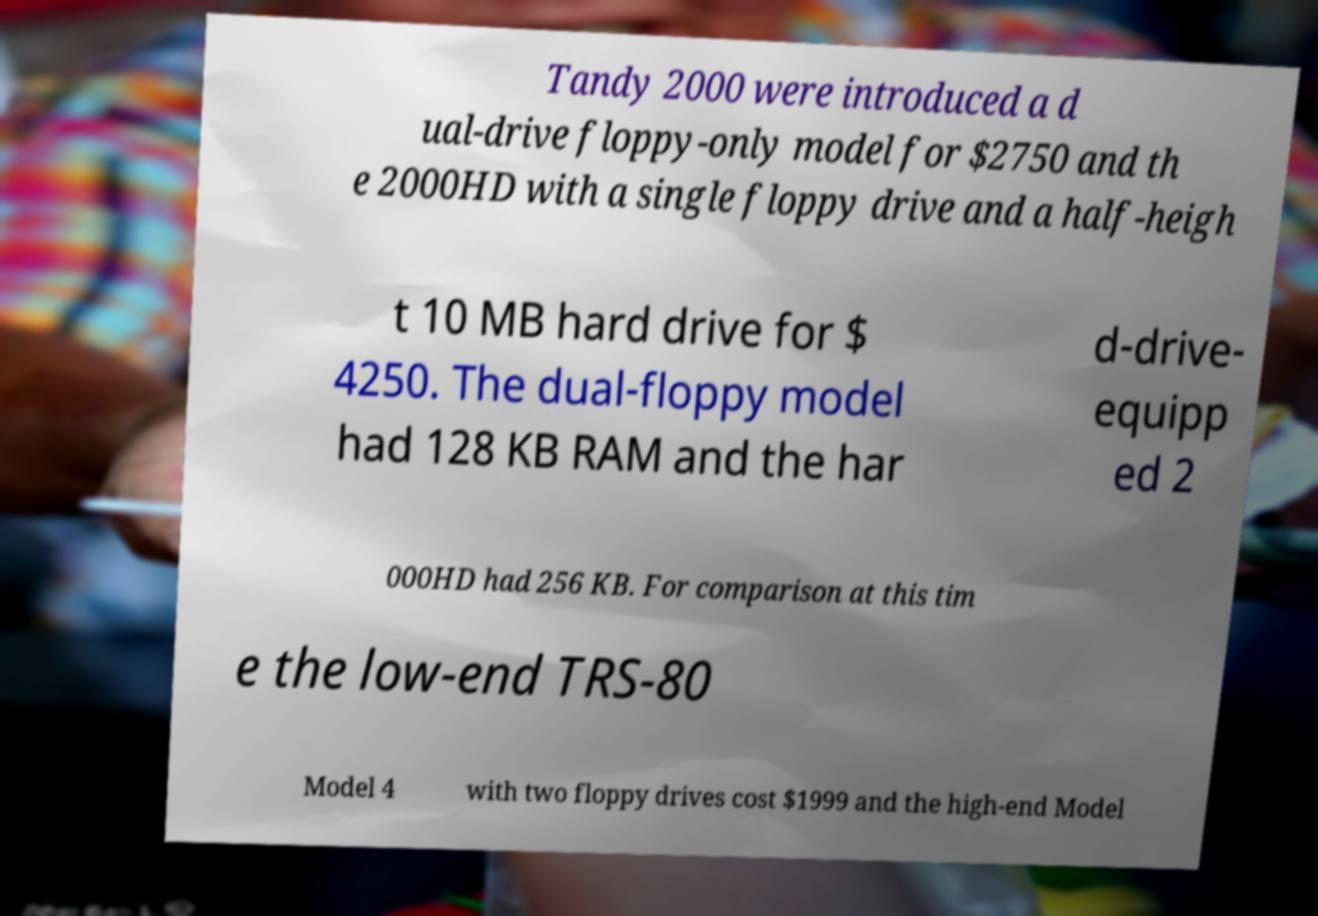Please read and relay the text visible in this image. What does it say? Tandy 2000 were introduced a d ual-drive floppy-only model for $2750 and th e 2000HD with a single floppy drive and a half-heigh t 10 MB hard drive for $ 4250. The dual-floppy model had 128 KB RAM and the har d-drive- equipp ed 2 000HD had 256 KB. For comparison at this tim e the low-end TRS-80 Model 4 with two floppy drives cost $1999 and the high-end Model 